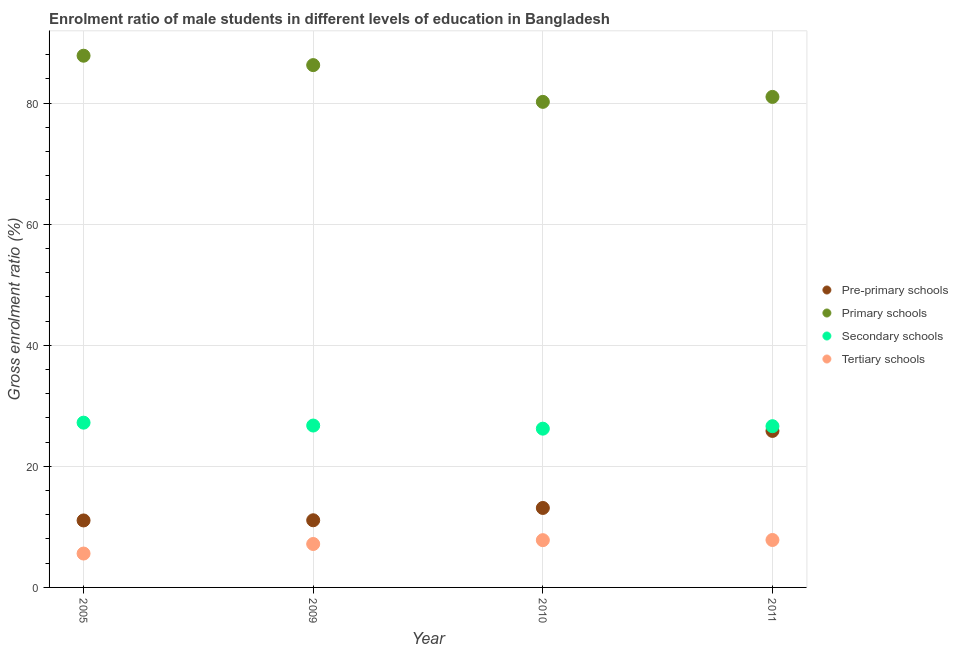How many different coloured dotlines are there?
Your answer should be very brief. 4. Is the number of dotlines equal to the number of legend labels?
Offer a terse response. Yes. What is the gross enrolment ratio(female) in primary schools in 2011?
Offer a terse response. 81.03. Across all years, what is the maximum gross enrolment ratio(female) in primary schools?
Ensure brevity in your answer.  87.83. Across all years, what is the minimum gross enrolment ratio(female) in tertiary schools?
Offer a terse response. 5.6. In which year was the gross enrolment ratio(female) in tertiary schools maximum?
Offer a very short reply. 2011. What is the total gross enrolment ratio(female) in tertiary schools in the graph?
Provide a short and direct response. 28.41. What is the difference between the gross enrolment ratio(female) in tertiary schools in 2005 and that in 2010?
Keep it short and to the point. -2.21. What is the difference between the gross enrolment ratio(female) in secondary schools in 2011 and the gross enrolment ratio(female) in tertiary schools in 2009?
Offer a terse response. 19.46. What is the average gross enrolment ratio(female) in pre-primary schools per year?
Offer a very short reply. 15.28. In the year 2009, what is the difference between the gross enrolment ratio(female) in pre-primary schools and gross enrolment ratio(female) in primary schools?
Your answer should be very brief. -75.19. What is the ratio of the gross enrolment ratio(female) in primary schools in 2005 to that in 2011?
Your answer should be compact. 1.08. Is the difference between the gross enrolment ratio(female) in tertiary schools in 2009 and 2010 greater than the difference between the gross enrolment ratio(female) in secondary schools in 2009 and 2010?
Keep it short and to the point. No. What is the difference between the highest and the second highest gross enrolment ratio(female) in secondary schools?
Ensure brevity in your answer.  0.48. What is the difference between the highest and the lowest gross enrolment ratio(female) in primary schools?
Your answer should be very brief. 7.62. In how many years, is the gross enrolment ratio(female) in pre-primary schools greater than the average gross enrolment ratio(female) in pre-primary schools taken over all years?
Offer a terse response. 1. Is it the case that in every year, the sum of the gross enrolment ratio(female) in tertiary schools and gross enrolment ratio(female) in primary schools is greater than the sum of gross enrolment ratio(female) in pre-primary schools and gross enrolment ratio(female) in secondary schools?
Give a very brief answer. Yes. Is the gross enrolment ratio(female) in pre-primary schools strictly greater than the gross enrolment ratio(female) in secondary schools over the years?
Keep it short and to the point. No. How many dotlines are there?
Keep it short and to the point. 4. How many years are there in the graph?
Give a very brief answer. 4. Are the values on the major ticks of Y-axis written in scientific E-notation?
Offer a very short reply. No. Does the graph contain grids?
Provide a short and direct response. Yes. Where does the legend appear in the graph?
Your response must be concise. Center right. What is the title of the graph?
Your answer should be compact. Enrolment ratio of male students in different levels of education in Bangladesh. Does "Services" appear as one of the legend labels in the graph?
Provide a succinct answer. No. What is the Gross enrolment ratio (%) in Pre-primary schools in 2005?
Your answer should be very brief. 11.06. What is the Gross enrolment ratio (%) in Primary schools in 2005?
Offer a terse response. 87.83. What is the Gross enrolment ratio (%) in Secondary schools in 2005?
Your response must be concise. 27.22. What is the Gross enrolment ratio (%) of Tertiary schools in 2005?
Offer a terse response. 5.6. What is the Gross enrolment ratio (%) in Pre-primary schools in 2009?
Provide a succinct answer. 11.09. What is the Gross enrolment ratio (%) in Primary schools in 2009?
Offer a terse response. 86.28. What is the Gross enrolment ratio (%) of Secondary schools in 2009?
Offer a very short reply. 26.74. What is the Gross enrolment ratio (%) of Tertiary schools in 2009?
Ensure brevity in your answer.  7.17. What is the Gross enrolment ratio (%) of Pre-primary schools in 2010?
Your answer should be very brief. 13.13. What is the Gross enrolment ratio (%) in Primary schools in 2010?
Ensure brevity in your answer.  80.21. What is the Gross enrolment ratio (%) in Secondary schools in 2010?
Ensure brevity in your answer.  26.23. What is the Gross enrolment ratio (%) of Tertiary schools in 2010?
Make the answer very short. 7.81. What is the Gross enrolment ratio (%) of Pre-primary schools in 2011?
Provide a short and direct response. 25.85. What is the Gross enrolment ratio (%) of Primary schools in 2011?
Offer a very short reply. 81.03. What is the Gross enrolment ratio (%) in Secondary schools in 2011?
Give a very brief answer. 26.63. What is the Gross enrolment ratio (%) of Tertiary schools in 2011?
Provide a succinct answer. 7.84. Across all years, what is the maximum Gross enrolment ratio (%) in Pre-primary schools?
Your answer should be very brief. 25.85. Across all years, what is the maximum Gross enrolment ratio (%) of Primary schools?
Give a very brief answer. 87.83. Across all years, what is the maximum Gross enrolment ratio (%) in Secondary schools?
Make the answer very short. 27.22. Across all years, what is the maximum Gross enrolment ratio (%) of Tertiary schools?
Your answer should be compact. 7.84. Across all years, what is the minimum Gross enrolment ratio (%) of Pre-primary schools?
Your response must be concise. 11.06. Across all years, what is the minimum Gross enrolment ratio (%) in Primary schools?
Keep it short and to the point. 80.21. Across all years, what is the minimum Gross enrolment ratio (%) in Secondary schools?
Your answer should be very brief. 26.23. Across all years, what is the minimum Gross enrolment ratio (%) of Tertiary schools?
Provide a short and direct response. 5.6. What is the total Gross enrolment ratio (%) in Pre-primary schools in the graph?
Offer a very short reply. 61.14. What is the total Gross enrolment ratio (%) in Primary schools in the graph?
Offer a very short reply. 335.35. What is the total Gross enrolment ratio (%) of Secondary schools in the graph?
Your answer should be compact. 106.82. What is the total Gross enrolment ratio (%) in Tertiary schools in the graph?
Your answer should be compact. 28.41. What is the difference between the Gross enrolment ratio (%) in Pre-primary schools in 2005 and that in 2009?
Your answer should be very brief. -0.03. What is the difference between the Gross enrolment ratio (%) of Primary schools in 2005 and that in 2009?
Your answer should be very brief. 1.55. What is the difference between the Gross enrolment ratio (%) of Secondary schools in 2005 and that in 2009?
Offer a very short reply. 0.48. What is the difference between the Gross enrolment ratio (%) in Tertiary schools in 2005 and that in 2009?
Make the answer very short. -1.58. What is the difference between the Gross enrolment ratio (%) in Pre-primary schools in 2005 and that in 2010?
Provide a short and direct response. -2.06. What is the difference between the Gross enrolment ratio (%) of Primary schools in 2005 and that in 2010?
Your response must be concise. 7.62. What is the difference between the Gross enrolment ratio (%) of Secondary schools in 2005 and that in 2010?
Your answer should be compact. 0.99. What is the difference between the Gross enrolment ratio (%) of Tertiary schools in 2005 and that in 2010?
Your answer should be very brief. -2.21. What is the difference between the Gross enrolment ratio (%) in Pre-primary schools in 2005 and that in 2011?
Offer a terse response. -14.79. What is the difference between the Gross enrolment ratio (%) in Primary schools in 2005 and that in 2011?
Your answer should be compact. 6.8. What is the difference between the Gross enrolment ratio (%) in Secondary schools in 2005 and that in 2011?
Provide a succinct answer. 0.58. What is the difference between the Gross enrolment ratio (%) of Tertiary schools in 2005 and that in 2011?
Make the answer very short. -2.24. What is the difference between the Gross enrolment ratio (%) in Pre-primary schools in 2009 and that in 2010?
Your answer should be compact. -2.03. What is the difference between the Gross enrolment ratio (%) in Primary schools in 2009 and that in 2010?
Your answer should be compact. 6.07. What is the difference between the Gross enrolment ratio (%) in Secondary schools in 2009 and that in 2010?
Keep it short and to the point. 0.52. What is the difference between the Gross enrolment ratio (%) in Tertiary schools in 2009 and that in 2010?
Offer a terse response. -0.63. What is the difference between the Gross enrolment ratio (%) of Pre-primary schools in 2009 and that in 2011?
Give a very brief answer. -14.76. What is the difference between the Gross enrolment ratio (%) in Primary schools in 2009 and that in 2011?
Give a very brief answer. 5.25. What is the difference between the Gross enrolment ratio (%) in Secondary schools in 2009 and that in 2011?
Your answer should be compact. 0.11. What is the difference between the Gross enrolment ratio (%) of Tertiary schools in 2009 and that in 2011?
Offer a terse response. -0.66. What is the difference between the Gross enrolment ratio (%) of Pre-primary schools in 2010 and that in 2011?
Your answer should be compact. -12.73. What is the difference between the Gross enrolment ratio (%) of Primary schools in 2010 and that in 2011?
Offer a terse response. -0.82. What is the difference between the Gross enrolment ratio (%) of Secondary schools in 2010 and that in 2011?
Provide a succinct answer. -0.41. What is the difference between the Gross enrolment ratio (%) in Tertiary schools in 2010 and that in 2011?
Ensure brevity in your answer.  -0.03. What is the difference between the Gross enrolment ratio (%) of Pre-primary schools in 2005 and the Gross enrolment ratio (%) of Primary schools in 2009?
Your response must be concise. -75.22. What is the difference between the Gross enrolment ratio (%) in Pre-primary schools in 2005 and the Gross enrolment ratio (%) in Secondary schools in 2009?
Provide a succinct answer. -15.68. What is the difference between the Gross enrolment ratio (%) of Pre-primary schools in 2005 and the Gross enrolment ratio (%) of Tertiary schools in 2009?
Your response must be concise. 3.89. What is the difference between the Gross enrolment ratio (%) in Primary schools in 2005 and the Gross enrolment ratio (%) in Secondary schools in 2009?
Make the answer very short. 61.09. What is the difference between the Gross enrolment ratio (%) of Primary schools in 2005 and the Gross enrolment ratio (%) of Tertiary schools in 2009?
Give a very brief answer. 80.66. What is the difference between the Gross enrolment ratio (%) in Secondary schools in 2005 and the Gross enrolment ratio (%) in Tertiary schools in 2009?
Make the answer very short. 20.04. What is the difference between the Gross enrolment ratio (%) of Pre-primary schools in 2005 and the Gross enrolment ratio (%) of Primary schools in 2010?
Your answer should be very brief. -69.14. What is the difference between the Gross enrolment ratio (%) of Pre-primary schools in 2005 and the Gross enrolment ratio (%) of Secondary schools in 2010?
Provide a short and direct response. -15.16. What is the difference between the Gross enrolment ratio (%) in Pre-primary schools in 2005 and the Gross enrolment ratio (%) in Tertiary schools in 2010?
Make the answer very short. 3.26. What is the difference between the Gross enrolment ratio (%) of Primary schools in 2005 and the Gross enrolment ratio (%) of Secondary schools in 2010?
Offer a terse response. 61.61. What is the difference between the Gross enrolment ratio (%) of Primary schools in 2005 and the Gross enrolment ratio (%) of Tertiary schools in 2010?
Your answer should be compact. 80.02. What is the difference between the Gross enrolment ratio (%) in Secondary schools in 2005 and the Gross enrolment ratio (%) in Tertiary schools in 2010?
Your response must be concise. 19.41. What is the difference between the Gross enrolment ratio (%) of Pre-primary schools in 2005 and the Gross enrolment ratio (%) of Primary schools in 2011?
Offer a terse response. -69.97. What is the difference between the Gross enrolment ratio (%) of Pre-primary schools in 2005 and the Gross enrolment ratio (%) of Secondary schools in 2011?
Ensure brevity in your answer.  -15.57. What is the difference between the Gross enrolment ratio (%) of Pre-primary schools in 2005 and the Gross enrolment ratio (%) of Tertiary schools in 2011?
Offer a terse response. 3.23. What is the difference between the Gross enrolment ratio (%) in Primary schools in 2005 and the Gross enrolment ratio (%) in Secondary schools in 2011?
Your answer should be very brief. 61.2. What is the difference between the Gross enrolment ratio (%) in Primary schools in 2005 and the Gross enrolment ratio (%) in Tertiary schools in 2011?
Make the answer very short. 80. What is the difference between the Gross enrolment ratio (%) in Secondary schools in 2005 and the Gross enrolment ratio (%) in Tertiary schools in 2011?
Provide a short and direct response. 19.38. What is the difference between the Gross enrolment ratio (%) in Pre-primary schools in 2009 and the Gross enrolment ratio (%) in Primary schools in 2010?
Your answer should be very brief. -69.11. What is the difference between the Gross enrolment ratio (%) of Pre-primary schools in 2009 and the Gross enrolment ratio (%) of Secondary schools in 2010?
Make the answer very short. -15.13. What is the difference between the Gross enrolment ratio (%) of Pre-primary schools in 2009 and the Gross enrolment ratio (%) of Tertiary schools in 2010?
Your response must be concise. 3.29. What is the difference between the Gross enrolment ratio (%) in Primary schools in 2009 and the Gross enrolment ratio (%) in Secondary schools in 2010?
Give a very brief answer. 60.05. What is the difference between the Gross enrolment ratio (%) of Primary schools in 2009 and the Gross enrolment ratio (%) of Tertiary schools in 2010?
Make the answer very short. 78.47. What is the difference between the Gross enrolment ratio (%) of Secondary schools in 2009 and the Gross enrolment ratio (%) of Tertiary schools in 2010?
Provide a succinct answer. 18.93. What is the difference between the Gross enrolment ratio (%) in Pre-primary schools in 2009 and the Gross enrolment ratio (%) in Primary schools in 2011?
Provide a succinct answer. -69.94. What is the difference between the Gross enrolment ratio (%) of Pre-primary schools in 2009 and the Gross enrolment ratio (%) of Secondary schools in 2011?
Offer a very short reply. -15.54. What is the difference between the Gross enrolment ratio (%) of Pre-primary schools in 2009 and the Gross enrolment ratio (%) of Tertiary schools in 2011?
Your response must be concise. 3.26. What is the difference between the Gross enrolment ratio (%) in Primary schools in 2009 and the Gross enrolment ratio (%) in Secondary schools in 2011?
Offer a terse response. 59.65. What is the difference between the Gross enrolment ratio (%) of Primary schools in 2009 and the Gross enrolment ratio (%) of Tertiary schools in 2011?
Your response must be concise. 78.44. What is the difference between the Gross enrolment ratio (%) of Secondary schools in 2009 and the Gross enrolment ratio (%) of Tertiary schools in 2011?
Your answer should be very brief. 18.91. What is the difference between the Gross enrolment ratio (%) in Pre-primary schools in 2010 and the Gross enrolment ratio (%) in Primary schools in 2011?
Offer a terse response. -67.9. What is the difference between the Gross enrolment ratio (%) of Pre-primary schools in 2010 and the Gross enrolment ratio (%) of Secondary schools in 2011?
Ensure brevity in your answer.  -13.51. What is the difference between the Gross enrolment ratio (%) in Pre-primary schools in 2010 and the Gross enrolment ratio (%) in Tertiary schools in 2011?
Provide a succinct answer. 5.29. What is the difference between the Gross enrolment ratio (%) in Primary schools in 2010 and the Gross enrolment ratio (%) in Secondary schools in 2011?
Give a very brief answer. 53.57. What is the difference between the Gross enrolment ratio (%) in Primary schools in 2010 and the Gross enrolment ratio (%) in Tertiary schools in 2011?
Offer a terse response. 72.37. What is the difference between the Gross enrolment ratio (%) of Secondary schools in 2010 and the Gross enrolment ratio (%) of Tertiary schools in 2011?
Offer a terse response. 18.39. What is the average Gross enrolment ratio (%) in Pre-primary schools per year?
Give a very brief answer. 15.28. What is the average Gross enrolment ratio (%) in Primary schools per year?
Your answer should be compact. 83.84. What is the average Gross enrolment ratio (%) in Secondary schools per year?
Keep it short and to the point. 26.7. What is the average Gross enrolment ratio (%) in Tertiary schools per year?
Your response must be concise. 7.1. In the year 2005, what is the difference between the Gross enrolment ratio (%) in Pre-primary schools and Gross enrolment ratio (%) in Primary schools?
Your answer should be compact. -76.77. In the year 2005, what is the difference between the Gross enrolment ratio (%) of Pre-primary schools and Gross enrolment ratio (%) of Secondary schools?
Provide a succinct answer. -16.15. In the year 2005, what is the difference between the Gross enrolment ratio (%) of Pre-primary schools and Gross enrolment ratio (%) of Tertiary schools?
Provide a succinct answer. 5.47. In the year 2005, what is the difference between the Gross enrolment ratio (%) of Primary schools and Gross enrolment ratio (%) of Secondary schools?
Provide a succinct answer. 60.61. In the year 2005, what is the difference between the Gross enrolment ratio (%) in Primary schools and Gross enrolment ratio (%) in Tertiary schools?
Provide a succinct answer. 82.23. In the year 2005, what is the difference between the Gross enrolment ratio (%) in Secondary schools and Gross enrolment ratio (%) in Tertiary schools?
Your answer should be compact. 21.62. In the year 2009, what is the difference between the Gross enrolment ratio (%) of Pre-primary schools and Gross enrolment ratio (%) of Primary schools?
Give a very brief answer. -75.19. In the year 2009, what is the difference between the Gross enrolment ratio (%) in Pre-primary schools and Gross enrolment ratio (%) in Secondary schools?
Ensure brevity in your answer.  -15.65. In the year 2009, what is the difference between the Gross enrolment ratio (%) of Pre-primary schools and Gross enrolment ratio (%) of Tertiary schools?
Offer a terse response. 3.92. In the year 2009, what is the difference between the Gross enrolment ratio (%) in Primary schools and Gross enrolment ratio (%) in Secondary schools?
Make the answer very short. 59.54. In the year 2009, what is the difference between the Gross enrolment ratio (%) of Primary schools and Gross enrolment ratio (%) of Tertiary schools?
Ensure brevity in your answer.  79.1. In the year 2009, what is the difference between the Gross enrolment ratio (%) of Secondary schools and Gross enrolment ratio (%) of Tertiary schools?
Your response must be concise. 19.57. In the year 2010, what is the difference between the Gross enrolment ratio (%) in Pre-primary schools and Gross enrolment ratio (%) in Primary schools?
Offer a terse response. -67.08. In the year 2010, what is the difference between the Gross enrolment ratio (%) of Pre-primary schools and Gross enrolment ratio (%) of Secondary schools?
Give a very brief answer. -13.1. In the year 2010, what is the difference between the Gross enrolment ratio (%) of Pre-primary schools and Gross enrolment ratio (%) of Tertiary schools?
Your answer should be very brief. 5.32. In the year 2010, what is the difference between the Gross enrolment ratio (%) of Primary schools and Gross enrolment ratio (%) of Secondary schools?
Provide a short and direct response. 53.98. In the year 2010, what is the difference between the Gross enrolment ratio (%) of Primary schools and Gross enrolment ratio (%) of Tertiary schools?
Provide a short and direct response. 72.4. In the year 2010, what is the difference between the Gross enrolment ratio (%) of Secondary schools and Gross enrolment ratio (%) of Tertiary schools?
Your answer should be very brief. 18.42. In the year 2011, what is the difference between the Gross enrolment ratio (%) of Pre-primary schools and Gross enrolment ratio (%) of Primary schools?
Give a very brief answer. -55.18. In the year 2011, what is the difference between the Gross enrolment ratio (%) in Pre-primary schools and Gross enrolment ratio (%) in Secondary schools?
Make the answer very short. -0.78. In the year 2011, what is the difference between the Gross enrolment ratio (%) in Pre-primary schools and Gross enrolment ratio (%) in Tertiary schools?
Provide a succinct answer. 18.02. In the year 2011, what is the difference between the Gross enrolment ratio (%) in Primary schools and Gross enrolment ratio (%) in Secondary schools?
Your response must be concise. 54.39. In the year 2011, what is the difference between the Gross enrolment ratio (%) of Primary schools and Gross enrolment ratio (%) of Tertiary schools?
Ensure brevity in your answer.  73.19. In the year 2011, what is the difference between the Gross enrolment ratio (%) in Secondary schools and Gross enrolment ratio (%) in Tertiary schools?
Your answer should be compact. 18.8. What is the ratio of the Gross enrolment ratio (%) of Pre-primary schools in 2005 to that in 2009?
Provide a succinct answer. 1. What is the ratio of the Gross enrolment ratio (%) of Primary schools in 2005 to that in 2009?
Keep it short and to the point. 1.02. What is the ratio of the Gross enrolment ratio (%) of Secondary schools in 2005 to that in 2009?
Offer a very short reply. 1.02. What is the ratio of the Gross enrolment ratio (%) in Tertiary schools in 2005 to that in 2009?
Ensure brevity in your answer.  0.78. What is the ratio of the Gross enrolment ratio (%) of Pre-primary schools in 2005 to that in 2010?
Give a very brief answer. 0.84. What is the ratio of the Gross enrolment ratio (%) in Primary schools in 2005 to that in 2010?
Provide a succinct answer. 1.09. What is the ratio of the Gross enrolment ratio (%) of Secondary schools in 2005 to that in 2010?
Make the answer very short. 1.04. What is the ratio of the Gross enrolment ratio (%) in Tertiary schools in 2005 to that in 2010?
Offer a terse response. 0.72. What is the ratio of the Gross enrolment ratio (%) of Pre-primary schools in 2005 to that in 2011?
Give a very brief answer. 0.43. What is the ratio of the Gross enrolment ratio (%) in Primary schools in 2005 to that in 2011?
Ensure brevity in your answer.  1.08. What is the ratio of the Gross enrolment ratio (%) in Secondary schools in 2005 to that in 2011?
Your response must be concise. 1.02. What is the ratio of the Gross enrolment ratio (%) in Tertiary schools in 2005 to that in 2011?
Ensure brevity in your answer.  0.71. What is the ratio of the Gross enrolment ratio (%) in Pre-primary schools in 2009 to that in 2010?
Your answer should be very brief. 0.85. What is the ratio of the Gross enrolment ratio (%) of Primary schools in 2009 to that in 2010?
Keep it short and to the point. 1.08. What is the ratio of the Gross enrolment ratio (%) of Secondary schools in 2009 to that in 2010?
Make the answer very short. 1.02. What is the ratio of the Gross enrolment ratio (%) of Tertiary schools in 2009 to that in 2010?
Offer a very short reply. 0.92. What is the ratio of the Gross enrolment ratio (%) in Pre-primary schools in 2009 to that in 2011?
Keep it short and to the point. 0.43. What is the ratio of the Gross enrolment ratio (%) in Primary schools in 2009 to that in 2011?
Your response must be concise. 1.06. What is the ratio of the Gross enrolment ratio (%) of Tertiary schools in 2009 to that in 2011?
Your response must be concise. 0.92. What is the ratio of the Gross enrolment ratio (%) in Pre-primary schools in 2010 to that in 2011?
Provide a succinct answer. 0.51. What is the ratio of the Gross enrolment ratio (%) of Primary schools in 2010 to that in 2011?
Your answer should be compact. 0.99. What is the ratio of the Gross enrolment ratio (%) of Secondary schools in 2010 to that in 2011?
Provide a succinct answer. 0.98. What is the ratio of the Gross enrolment ratio (%) in Tertiary schools in 2010 to that in 2011?
Ensure brevity in your answer.  1. What is the difference between the highest and the second highest Gross enrolment ratio (%) of Pre-primary schools?
Make the answer very short. 12.73. What is the difference between the highest and the second highest Gross enrolment ratio (%) in Primary schools?
Ensure brevity in your answer.  1.55. What is the difference between the highest and the second highest Gross enrolment ratio (%) in Secondary schools?
Provide a succinct answer. 0.48. What is the difference between the highest and the second highest Gross enrolment ratio (%) in Tertiary schools?
Make the answer very short. 0.03. What is the difference between the highest and the lowest Gross enrolment ratio (%) in Pre-primary schools?
Provide a short and direct response. 14.79. What is the difference between the highest and the lowest Gross enrolment ratio (%) in Primary schools?
Keep it short and to the point. 7.62. What is the difference between the highest and the lowest Gross enrolment ratio (%) of Secondary schools?
Your response must be concise. 0.99. What is the difference between the highest and the lowest Gross enrolment ratio (%) of Tertiary schools?
Make the answer very short. 2.24. 